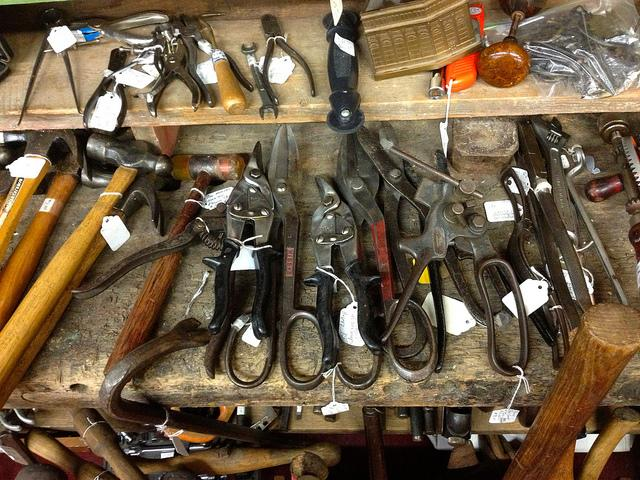Where would these tools be found? garage 